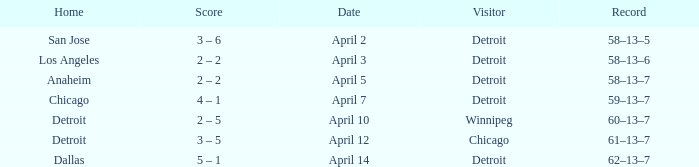What is the date of the game that had a visitor of Chicago? April 12. 